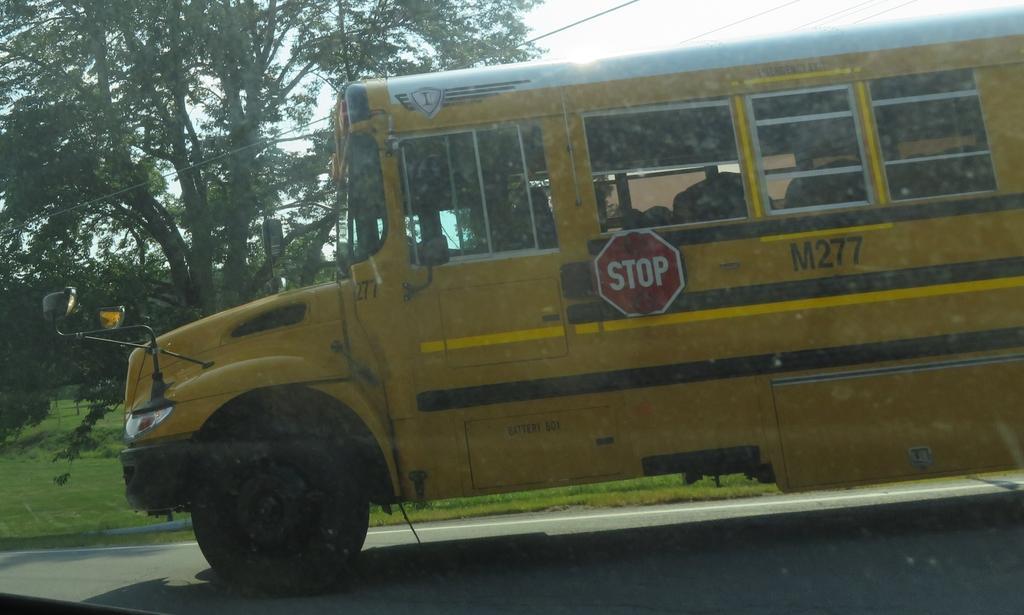Describe this image in one or two sentences. In the image we can see there is a bus parked on the road and there is a sign board on the bus on which it's written ¨Stop¨. There is ground covered with grass and behind there are trees. 